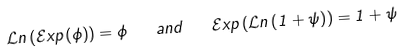<formula> <loc_0><loc_0><loc_500><loc_500>\mathcal { L } n \left ( \mathcal { E } x p \left ( \phi \right ) \right ) = \phi \quad a n d \quad \mathcal { E } x p \left ( \mathcal { L } n \left ( 1 + \psi \right ) \right ) = 1 + \psi \,</formula> 